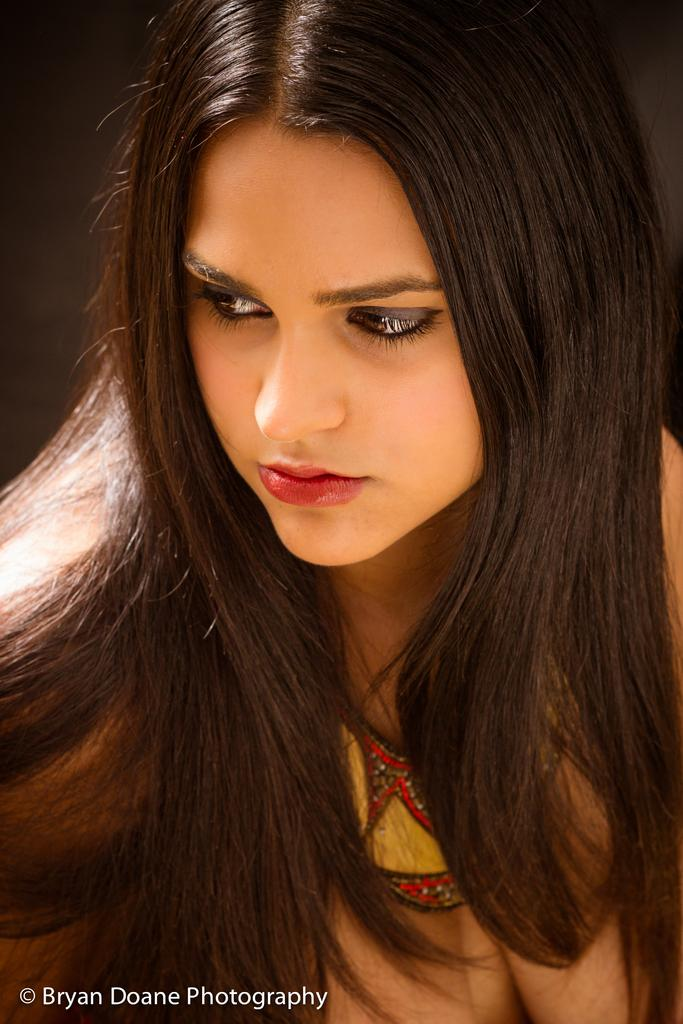Who is the main subject in the image? There is a woman in the image. What accessory is the woman wearing? The woman is wearing a necklace. Is there any text or marking at the bottom of the image? Yes, there is a watermark at the bottom of the image. How would you describe the background of the image? The background of the image appears blurry. How does the woman in the image provide comfort to her daughter? There is no daughter present in the image, and the woman's actions or intentions are not clear. 